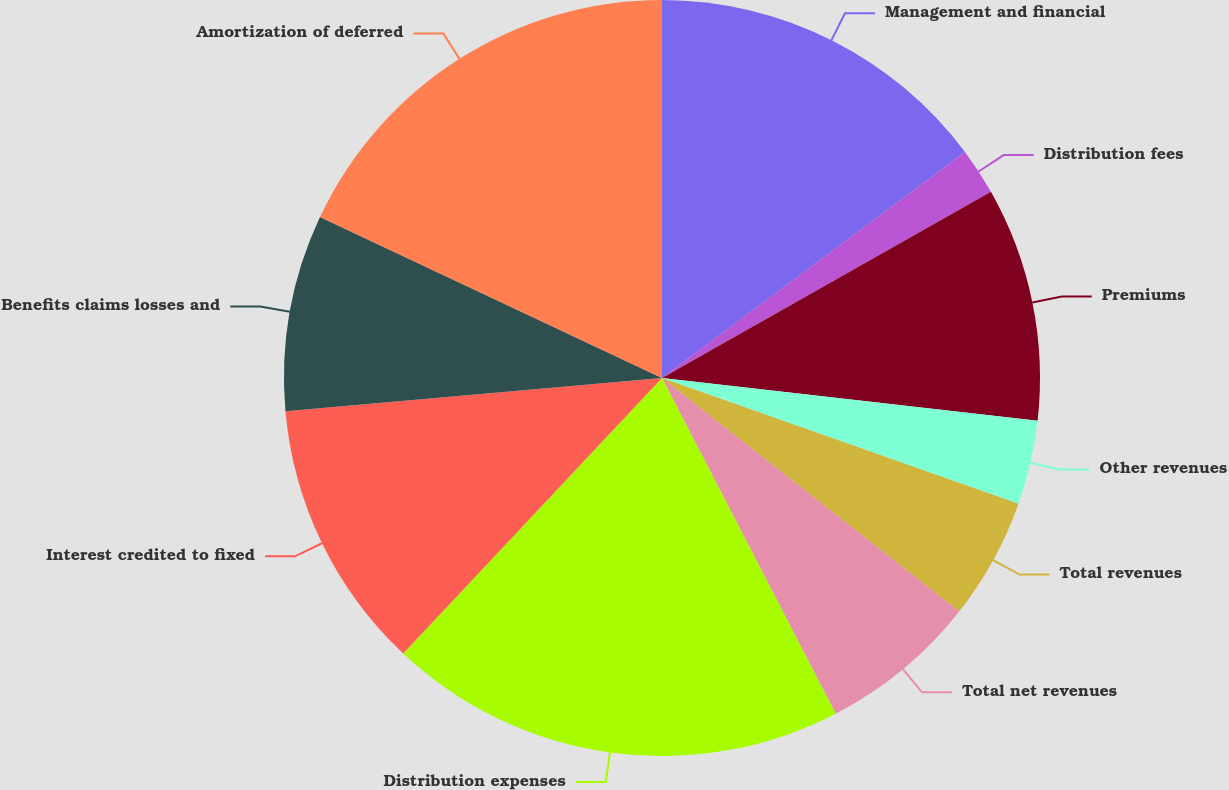<chart> <loc_0><loc_0><loc_500><loc_500><pie_chart><fcel>Management and financial<fcel>Distribution fees<fcel>Premiums<fcel>Other revenues<fcel>Total revenues<fcel>Total net revenues<fcel>Distribution expenses<fcel>Interest credited to fixed<fcel>Benefits claims losses and<fcel>Amortization of deferred<nl><fcel>14.8%<fcel>2.0%<fcel>10.0%<fcel>3.6%<fcel>5.2%<fcel>6.8%<fcel>19.6%<fcel>11.6%<fcel>8.4%<fcel>18.0%<nl></chart> 